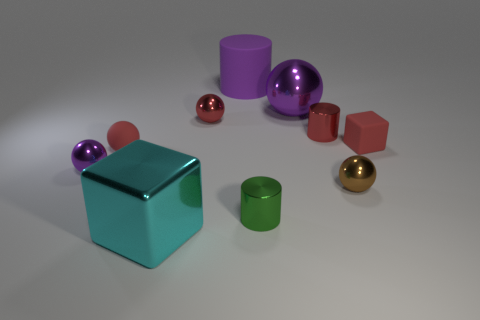Subtract 2 spheres. How many spheres are left? 3 Subtract all brown balls. How many balls are left? 4 Subtract all matte balls. How many balls are left? 4 Subtract all cyan spheres. Subtract all green cubes. How many spheres are left? 5 Subtract all blocks. How many objects are left? 8 Add 9 red rubber cubes. How many red rubber cubes exist? 10 Subtract 0 green spheres. How many objects are left? 10 Subtract all brown balls. Subtract all purple matte cylinders. How many objects are left? 8 Add 7 small red rubber cubes. How many small red rubber cubes are left? 8 